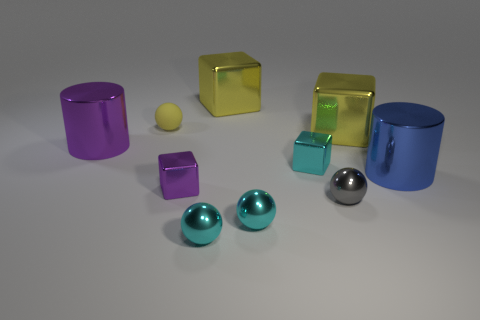Subtract all tiny purple cubes. How many cubes are left? 3 Subtract all gray cubes. How many cyan balls are left? 2 Subtract all cyan cubes. How many cubes are left? 3 Subtract all brown blocks. Subtract all brown spheres. How many blocks are left? 4 Subtract all blocks. How many objects are left? 6 Subtract 0 green cubes. How many objects are left? 10 Subtract all large blue shiny objects. Subtract all small yellow things. How many objects are left? 8 Add 3 yellow matte things. How many yellow matte things are left? 4 Add 9 brown matte cylinders. How many brown matte cylinders exist? 9 